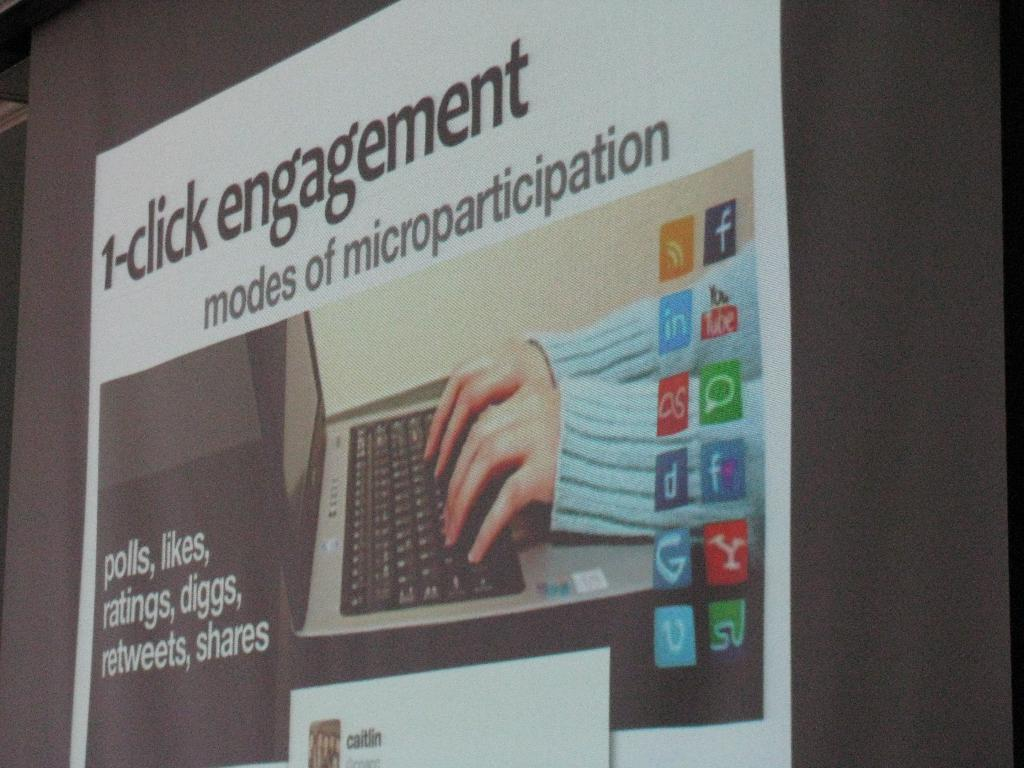<image>
Present a compact description of the photo's key features. The sign gives examples of microparticipation such as polls, ratings, shares, diggs, etc. 